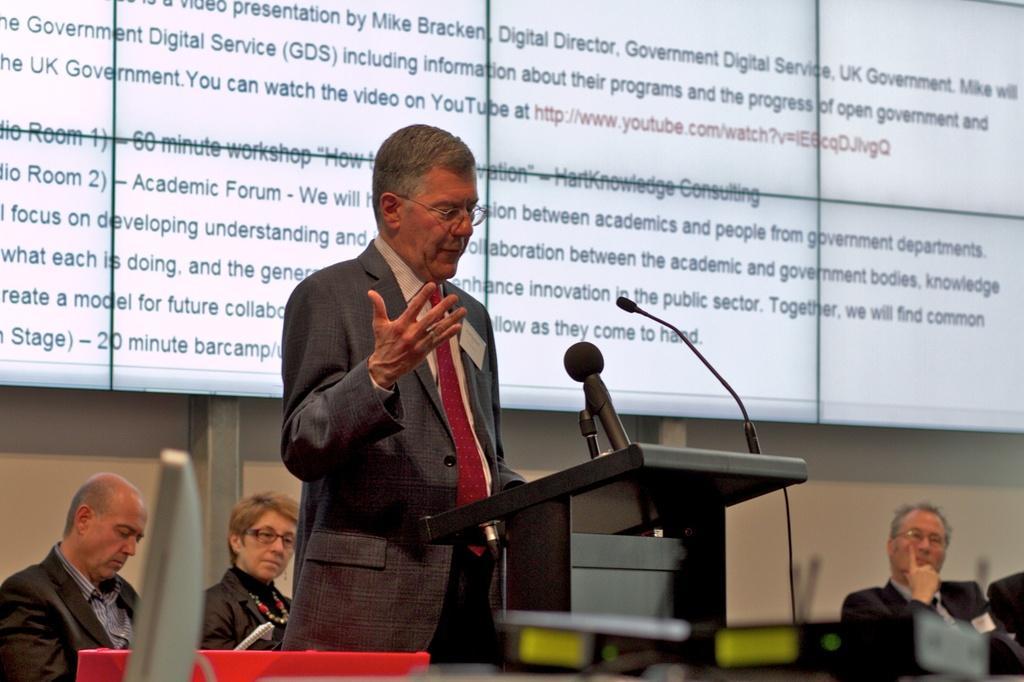Could you give a brief overview of what you see in this image? In the image we can see there is a man standing near the podium and there are 2 mics kept on the podium. There are people sitting on the chairs and they are wearing formal suits. Behind there is a projector screen. 